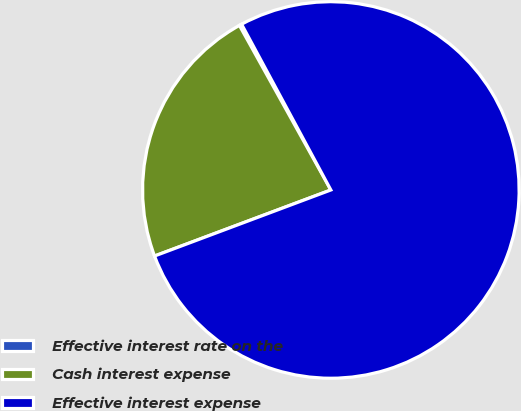Convert chart to OTSL. <chart><loc_0><loc_0><loc_500><loc_500><pie_chart><fcel>Effective interest rate on the<fcel>Cash interest expense<fcel>Effective interest expense<nl><fcel>0.21%<fcel>22.63%<fcel>77.15%<nl></chart> 